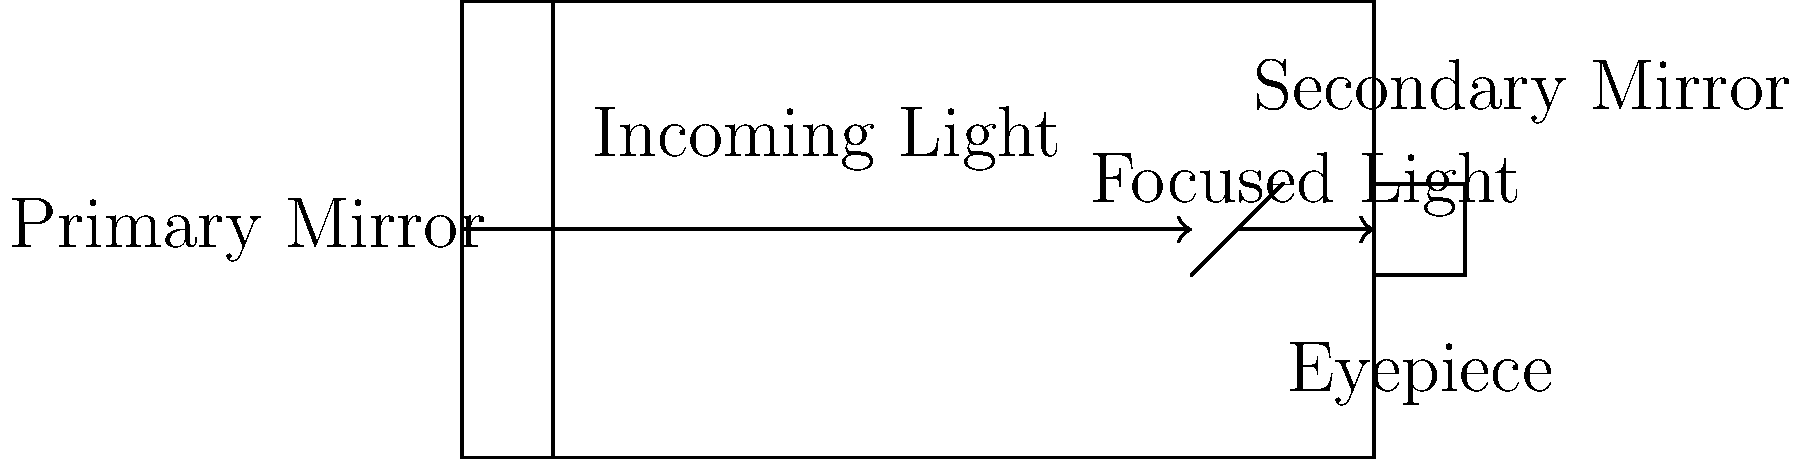In a reflecting telescope, how does the arrangement of mirrors influence the path of light, and how might this relate to the way a dancer's movements influence a pianist's musical choices? 1. Light enters the telescope tube from the left side of the diagram.

2. The incoming light strikes the primary mirror, which is concave and located at the back of the telescope. This mirror's shape is crucial, much like how a dancer's initial movements set the tone for a performance.

3. The primary mirror reflects the light towards the secondary mirror near the front of the telescope. This redirection is similar to how a dancer's change in direction can prompt a shift in the music's tempo or mood.

4. The secondary mirror, which is smaller and flat or slightly convex, reflects the light again, this time towards the eyepiece. This final reflection is like the culmination of a dance sequence, where the pianist might emphasize certain notes to match the dancer's final flourish.

5. The light enters the eyepiece, where it's magnified for viewing. This magnification is analogous to how a pianist might emphasize or elaborate on certain musical phrases to highlight specific dance movements.

6. The overall design of the telescope, with its precise arrangement of mirrors, allows for a clear and magnified image of distant objects. Similarly, the interplay between a dancer's movements and a pianist's musical choices creates a cohesive and expressive performance.

7. Just as the telescope's design determines its effectiveness in observing celestial objects, the synergy between dance and music determines the impact of a performance on the audience.
Answer: The mirrors redirect and focus light, similar to how dance movements influence musical choices. 